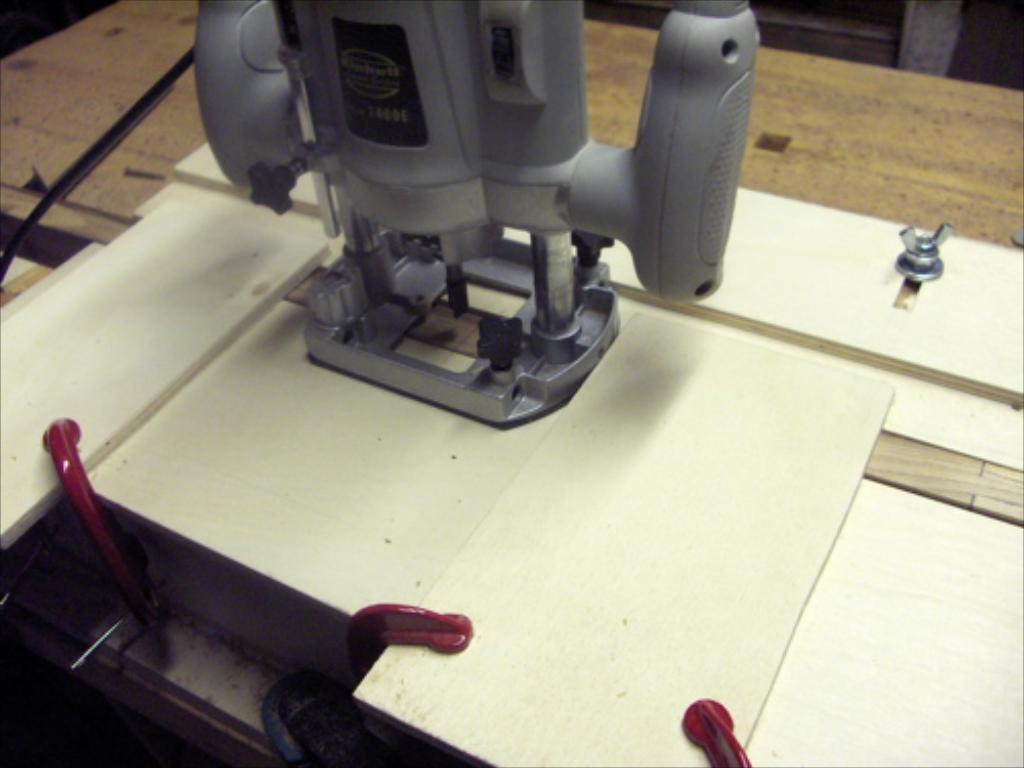Describe this image in one or two sentences. In this image we can see machine on the table. 